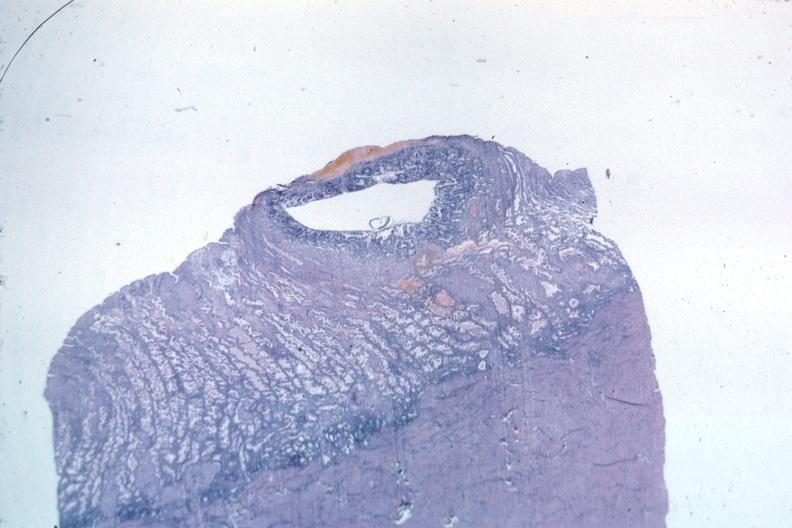what is present?
Answer the question using a single word or phrase. Uterus 